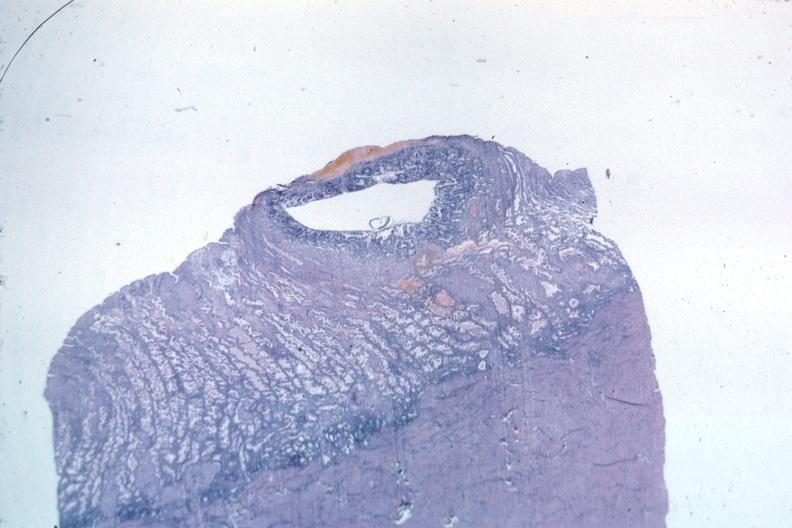what is present?
Answer the question using a single word or phrase. Uterus 